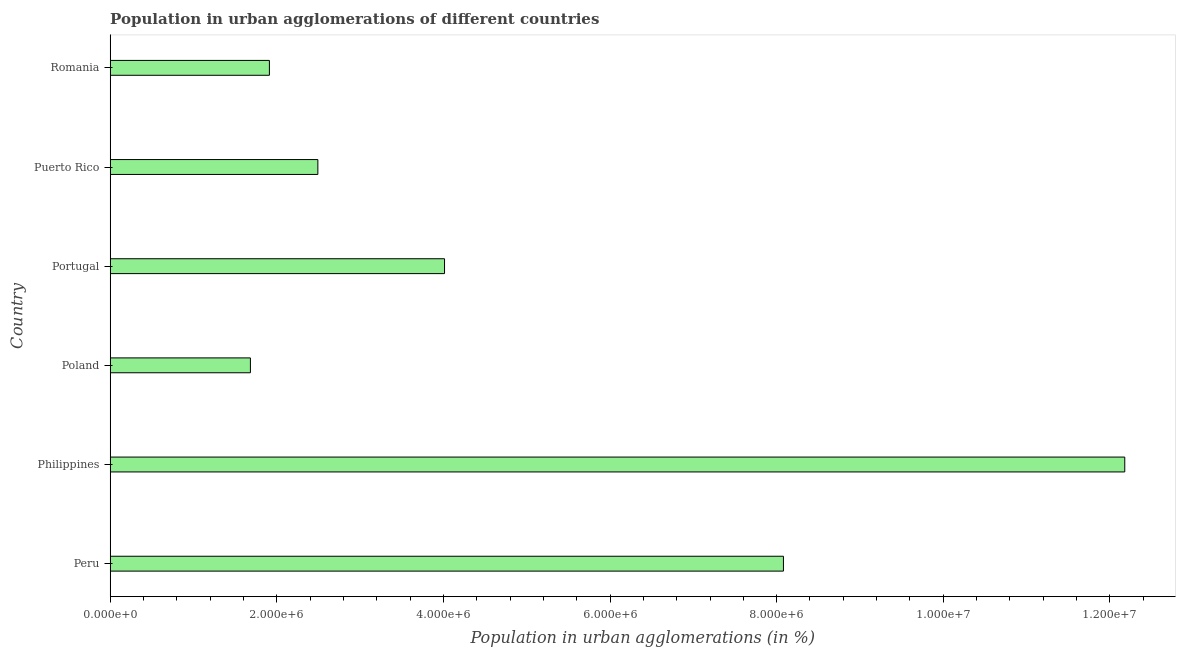Does the graph contain grids?
Your response must be concise. No. What is the title of the graph?
Your answer should be compact. Population in urban agglomerations of different countries. What is the label or title of the X-axis?
Offer a terse response. Population in urban agglomerations (in %). What is the label or title of the Y-axis?
Provide a succinct answer. Country. What is the population in urban agglomerations in Poland?
Your response must be concise. 1.68e+06. Across all countries, what is the maximum population in urban agglomerations?
Offer a terse response. 1.22e+07. Across all countries, what is the minimum population in urban agglomerations?
Provide a short and direct response. 1.68e+06. In which country was the population in urban agglomerations maximum?
Offer a very short reply. Philippines. In which country was the population in urban agglomerations minimum?
Ensure brevity in your answer.  Poland. What is the sum of the population in urban agglomerations?
Your answer should be very brief. 3.04e+07. What is the difference between the population in urban agglomerations in Philippines and Puerto Rico?
Make the answer very short. 9.68e+06. What is the average population in urban agglomerations per country?
Provide a short and direct response. 5.06e+06. What is the median population in urban agglomerations?
Make the answer very short. 3.25e+06. In how many countries, is the population in urban agglomerations greater than 4000000 %?
Offer a terse response. 3. What is the ratio of the population in urban agglomerations in Peru to that in Poland?
Ensure brevity in your answer.  4.8. What is the difference between the highest and the second highest population in urban agglomerations?
Your answer should be very brief. 4.10e+06. What is the difference between the highest and the lowest population in urban agglomerations?
Offer a terse response. 1.05e+07. In how many countries, is the population in urban agglomerations greater than the average population in urban agglomerations taken over all countries?
Your answer should be very brief. 2. How many bars are there?
Your answer should be very brief. 6. What is the Population in urban agglomerations (in %) of Peru?
Ensure brevity in your answer.  8.08e+06. What is the Population in urban agglomerations (in %) in Philippines?
Your response must be concise. 1.22e+07. What is the Population in urban agglomerations (in %) in Poland?
Your response must be concise. 1.68e+06. What is the Population in urban agglomerations (in %) in Portugal?
Provide a short and direct response. 4.01e+06. What is the Population in urban agglomerations (in %) of Puerto Rico?
Your answer should be compact. 2.49e+06. What is the Population in urban agglomerations (in %) in Romania?
Provide a short and direct response. 1.91e+06. What is the difference between the Population in urban agglomerations (in %) in Peru and Philippines?
Your answer should be compact. -4.10e+06. What is the difference between the Population in urban agglomerations (in %) in Peru and Poland?
Give a very brief answer. 6.40e+06. What is the difference between the Population in urban agglomerations (in %) in Peru and Portugal?
Keep it short and to the point. 4.07e+06. What is the difference between the Population in urban agglomerations (in %) in Peru and Puerto Rico?
Provide a succinct answer. 5.59e+06. What is the difference between the Population in urban agglomerations (in %) in Peru and Romania?
Provide a succinct answer. 6.17e+06. What is the difference between the Population in urban agglomerations (in %) in Philippines and Poland?
Ensure brevity in your answer.  1.05e+07. What is the difference between the Population in urban agglomerations (in %) in Philippines and Portugal?
Your response must be concise. 8.16e+06. What is the difference between the Population in urban agglomerations (in %) in Philippines and Puerto Rico?
Offer a terse response. 9.68e+06. What is the difference between the Population in urban agglomerations (in %) in Philippines and Romania?
Ensure brevity in your answer.  1.03e+07. What is the difference between the Population in urban agglomerations (in %) in Poland and Portugal?
Offer a terse response. -2.33e+06. What is the difference between the Population in urban agglomerations (in %) in Poland and Puerto Rico?
Give a very brief answer. -8.10e+05. What is the difference between the Population in urban agglomerations (in %) in Poland and Romania?
Provide a succinct answer. -2.28e+05. What is the difference between the Population in urban agglomerations (in %) in Portugal and Puerto Rico?
Give a very brief answer. 1.52e+06. What is the difference between the Population in urban agglomerations (in %) in Portugal and Romania?
Provide a succinct answer. 2.10e+06. What is the difference between the Population in urban agglomerations (in %) in Puerto Rico and Romania?
Offer a terse response. 5.82e+05. What is the ratio of the Population in urban agglomerations (in %) in Peru to that in Philippines?
Give a very brief answer. 0.66. What is the ratio of the Population in urban agglomerations (in %) in Peru to that in Portugal?
Your response must be concise. 2.01. What is the ratio of the Population in urban agglomerations (in %) in Peru to that in Puerto Rico?
Make the answer very short. 3.24. What is the ratio of the Population in urban agglomerations (in %) in Peru to that in Romania?
Offer a terse response. 4.23. What is the ratio of the Population in urban agglomerations (in %) in Philippines to that in Poland?
Keep it short and to the point. 7.23. What is the ratio of the Population in urban agglomerations (in %) in Philippines to that in Portugal?
Provide a succinct answer. 3.03. What is the ratio of the Population in urban agglomerations (in %) in Philippines to that in Puerto Rico?
Provide a succinct answer. 4.88. What is the ratio of the Population in urban agglomerations (in %) in Philippines to that in Romania?
Ensure brevity in your answer.  6.37. What is the ratio of the Population in urban agglomerations (in %) in Poland to that in Portugal?
Your response must be concise. 0.42. What is the ratio of the Population in urban agglomerations (in %) in Poland to that in Puerto Rico?
Provide a short and direct response. 0.68. What is the ratio of the Population in urban agglomerations (in %) in Poland to that in Romania?
Make the answer very short. 0.88. What is the ratio of the Population in urban agglomerations (in %) in Portugal to that in Puerto Rico?
Your answer should be compact. 1.61. What is the ratio of the Population in urban agglomerations (in %) in Puerto Rico to that in Romania?
Your answer should be very brief. 1.3. 